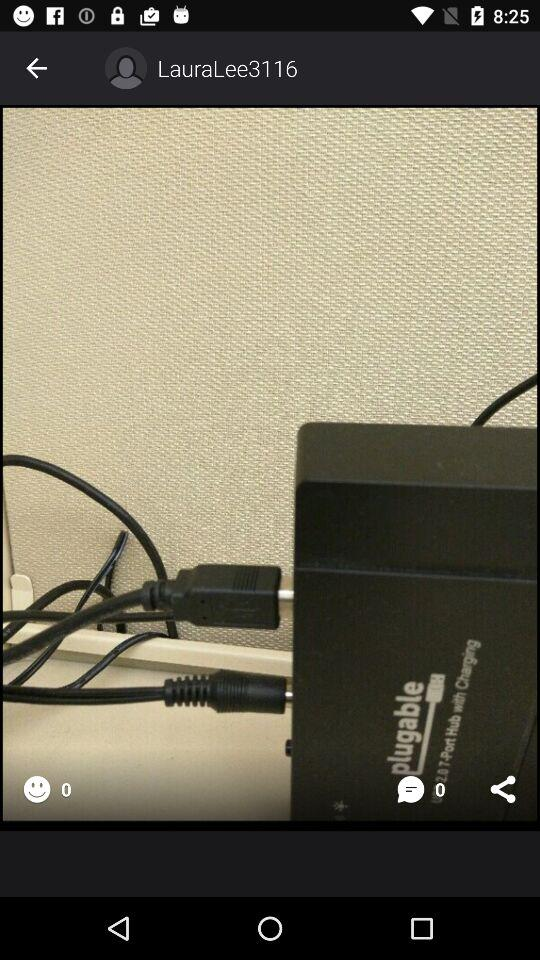How many comments are there? There are 0 comments. 